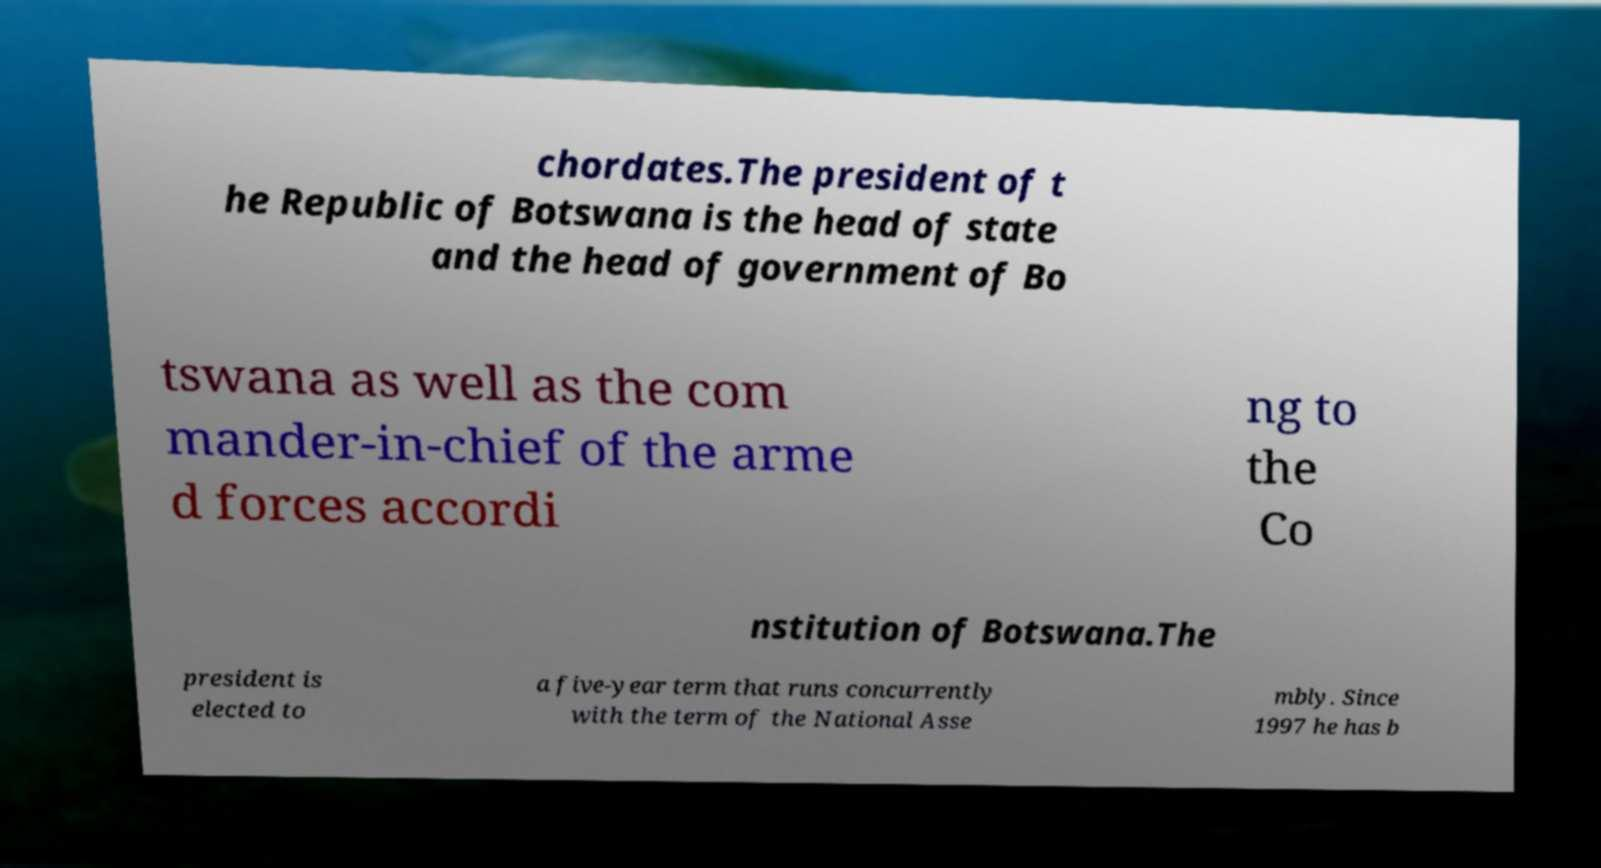Can you read and provide the text displayed in the image?This photo seems to have some interesting text. Can you extract and type it out for me? chordates.The president of t he Republic of Botswana is the head of state and the head of government of Bo tswana as well as the com mander-in-chief of the arme d forces accordi ng to the Co nstitution of Botswana.The president is elected to a five-year term that runs concurrently with the term of the National Asse mbly. Since 1997 he has b 